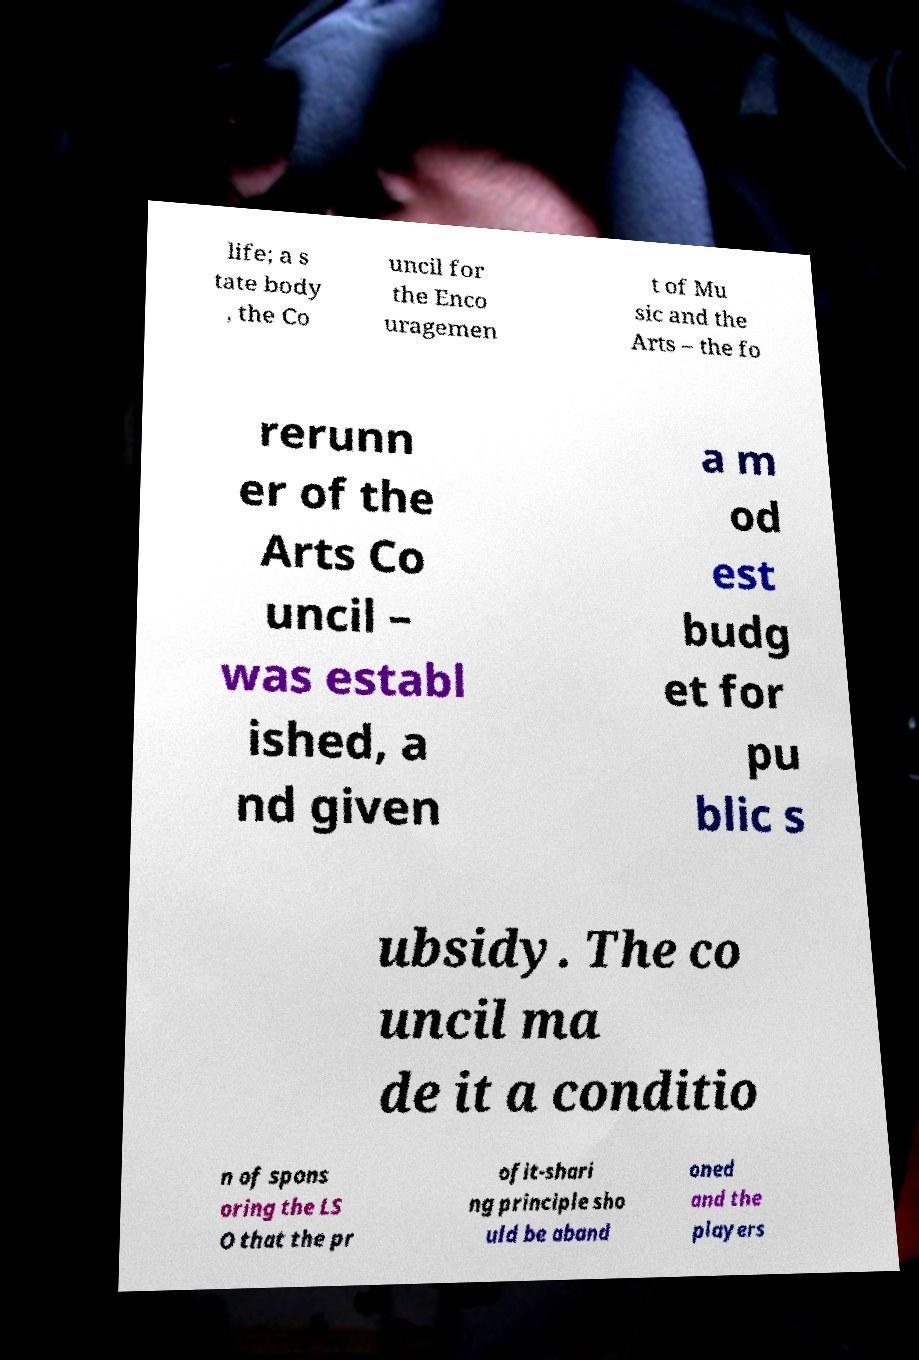Can you accurately transcribe the text from the provided image for me? life; a s tate body , the Co uncil for the Enco uragemen t of Mu sic and the Arts – the fo rerunn er of the Arts Co uncil – was establ ished, a nd given a m od est budg et for pu blic s ubsidy. The co uncil ma de it a conditio n of spons oring the LS O that the pr ofit-shari ng principle sho uld be aband oned and the players 